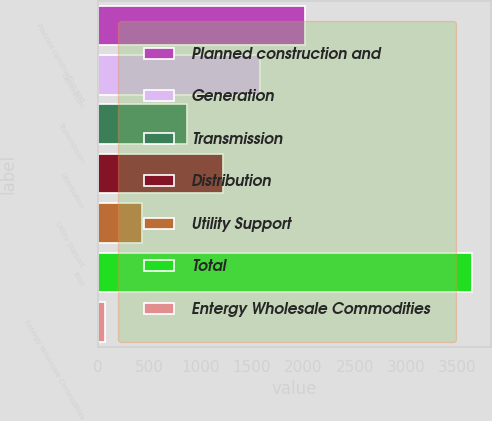Convert chart. <chart><loc_0><loc_0><loc_500><loc_500><bar_chart><fcel>Planned construction and<fcel>Generation<fcel>Transmission<fcel>Distribution<fcel>Utility Support<fcel>Total<fcel>Entergy Wholesale Commodities<nl><fcel>2019<fcel>1578<fcel>865<fcel>1221.5<fcel>431.5<fcel>3640<fcel>75<nl></chart> 